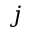Convert formula to latex. <formula><loc_0><loc_0><loc_500><loc_500>j</formula> 